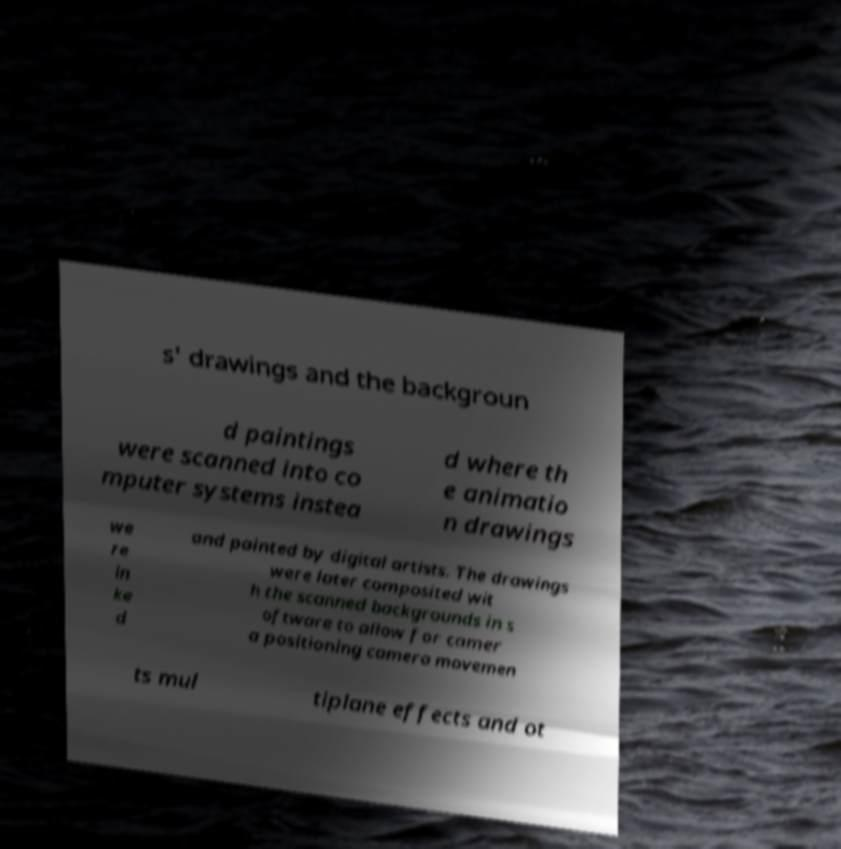Can you read and provide the text displayed in the image?This photo seems to have some interesting text. Can you extract and type it out for me? s' drawings and the backgroun d paintings were scanned into co mputer systems instea d where th e animatio n drawings we re in ke d and painted by digital artists. The drawings were later composited wit h the scanned backgrounds in s oftware to allow for camer a positioning camera movemen ts mul tiplane effects and ot 